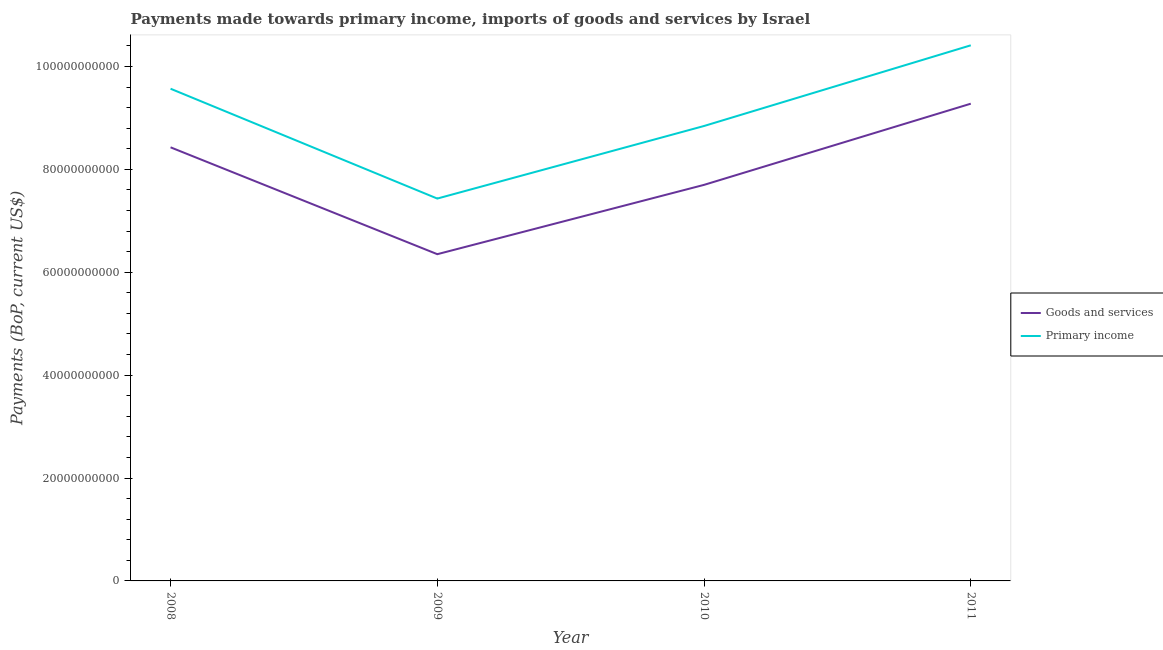What is the payments made towards goods and services in 2011?
Make the answer very short. 9.28e+1. Across all years, what is the maximum payments made towards goods and services?
Make the answer very short. 9.28e+1. Across all years, what is the minimum payments made towards primary income?
Keep it short and to the point. 7.43e+1. In which year was the payments made towards goods and services maximum?
Make the answer very short. 2011. What is the total payments made towards primary income in the graph?
Provide a succinct answer. 3.63e+11. What is the difference between the payments made towards goods and services in 2009 and that in 2011?
Keep it short and to the point. -2.93e+1. What is the difference between the payments made towards primary income in 2008 and the payments made towards goods and services in 2010?
Make the answer very short. 1.87e+1. What is the average payments made towards primary income per year?
Offer a terse response. 9.06e+1. In the year 2010, what is the difference between the payments made towards goods and services and payments made towards primary income?
Provide a succinct answer. -1.14e+1. What is the ratio of the payments made towards primary income in 2008 to that in 2010?
Keep it short and to the point. 1.08. Is the payments made towards goods and services in 2008 less than that in 2011?
Your answer should be compact. Yes. Is the difference between the payments made towards primary income in 2009 and 2011 greater than the difference between the payments made towards goods and services in 2009 and 2011?
Ensure brevity in your answer.  No. What is the difference between the highest and the second highest payments made towards primary income?
Offer a terse response. 8.44e+09. What is the difference between the highest and the lowest payments made towards goods and services?
Offer a very short reply. 2.93e+1. Does the payments made towards primary income monotonically increase over the years?
Ensure brevity in your answer.  No. How many lines are there?
Your answer should be compact. 2. How many years are there in the graph?
Make the answer very short. 4. What is the difference between two consecutive major ticks on the Y-axis?
Offer a very short reply. 2.00e+1. Are the values on the major ticks of Y-axis written in scientific E-notation?
Make the answer very short. No. How many legend labels are there?
Make the answer very short. 2. How are the legend labels stacked?
Provide a succinct answer. Vertical. What is the title of the graph?
Your answer should be compact. Payments made towards primary income, imports of goods and services by Israel. What is the label or title of the Y-axis?
Your response must be concise. Payments (BoP, current US$). What is the Payments (BoP, current US$) of Goods and services in 2008?
Give a very brief answer. 8.43e+1. What is the Payments (BoP, current US$) of Primary income in 2008?
Ensure brevity in your answer.  9.57e+1. What is the Payments (BoP, current US$) of Goods and services in 2009?
Your answer should be very brief. 6.35e+1. What is the Payments (BoP, current US$) in Primary income in 2009?
Give a very brief answer. 7.43e+1. What is the Payments (BoP, current US$) in Goods and services in 2010?
Your answer should be compact. 7.70e+1. What is the Payments (BoP, current US$) in Primary income in 2010?
Your answer should be compact. 8.84e+1. What is the Payments (BoP, current US$) of Goods and services in 2011?
Keep it short and to the point. 9.28e+1. What is the Payments (BoP, current US$) of Primary income in 2011?
Your response must be concise. 1.04e+11. Across all years, what is the maximum Payments (BoP, current US$) of Goods and services?
Provide a short and direct response. 9.28e+1. Across all years, what is the maximum Payments (BoP, current US$) in Primary income?
Your response must be concise. 1.04e+11. Across all years, what is the minimum Payments (BoP, current US$) of Goods and services?
Offer a terse response. 6.35e+1. Across all years, what is the minimum Payments (BoP, current US$) in Primary income?
Give a very brief answer. 7.43e+1. What is the total Payments (BoP, current US$) in Goods and services in the graph?
Provide a short and direct response. 3.18e+11. What is the total Payments (BoP, current US$) in Primary income in the graph?
Your response must be concise. 3.63e+11. What is the difference between the Payments (BoP, current US$) of Goods and services in 2008 and that in 2009?
Provide a short and direct response. 2.08e+1. What is the difference between the Payments (BoP, current US$) in Primary income in 2008 and that in 2009?
Give a very brief answer. 2.14e+1. What is the difference between the Payments (BoP, current US$) in Goods and services in 2008 and that in 2010?
Your answer should be compact. 7.30e+09. What is the difference between the Payments (BoP, current US$) in Primary income in 2008 and that in 2010?
Provide a short and direct response. 7.24e+09. What is the difference between the Payments (BoP, current US$) of Goods and services in 2008 and that in 2011?
Provide a succinct answer. -8.48e+09. What is the difference between the Payments (BoP, current US$) of Primary income in 2008 and that in 2011?
Provide a succinct answer. -8.44e+09. What is the difference between the Payments (BoP, current US$) in Goods and services in 2009 and that in 2010?
Ensure brevity in your answer.  -1.35e+1. What is the difference between the Payments (BoP, current US$) of Primary income in 2009 and that in 2010?
Give a very brief answer. -1.41e+1. What is the difference between the Payments (BoP, current US$) of Goods and services in 2009 and that in 2011?
Your answer should be very brief. -2.93e+1. What is the difference between the Payments (BoP, current US$) of Primary income in 2009 and that in 2011?
Your answer should be compact. -2.98e+1. What is the difference between the Payments (BoP, current US$) of Goods and services in 2010 and that in 2011?
Your response must be concise. -1.58e+1. What is the difference between the Payments (BoP, current US$) in Primary income in 2010 and that in 2011?
Your answer should be compact. -1.57e+1. What is the difference between the Payments (BoP, current US$) in Goods and services in 2008 and the Payments (BoP, current US$) in Primary income in 2009?
Your answer should be very brief. 9.96e+09. What is the difference between the Payments (BoP, current US$) of Goods and services in 2008 and the Payments (BoP, current US$) of Primary income in 2010?
Provide a succinct answer. -4.15e+09. What is the difference between the Payments (BoP, current US$) in Goods and services in 2008 and the Payments (BoP, current US$) in Primary income in 2011?
Provide a succinct answer. -1.98e+1. What is the difference between the Payments (BoP, current US$) of Goods and services in 2009 and the Payments (BoP, current US$) of Primary income in 2010?
Your answer should be very brief. -2.49e+1. What is the difference between the Payments (BoP, current US$) of Goods and services in 2009 and the Payments (BoP, current US$) of Primary income in 2011?
Your response must be concise. -4.06e+1. What is the difference between the Payments (BoP, current US$) of Goods and services in 2010 and the Payments (BoP, current US$) of Primary income in 2011?
Your answer should be very brief. -2.71e+1. What is the average Payments (BoP, current US$) in Goods and services per year?
Your response must be concise. 7.94e+1. What is the average Payments (BoP, current US$) in Primary income per year?
Provide a short and direct response. 9.06e+1. In the year 2008, what is the difference between the Payments (BoP, current US$) of Goods and services and Payments (BoP, current US$) of Primary income?
Provide a succinct answer. -1.14e+1. In the year 2009, what is the difference between the Payments (BoP, current US$) in Goods and services and Payments (BoP, current US$) in Primary income?
Provide a succinct answer. -1.08e+1. In the year 2010, what is the difference between the Payments (BoP, current US$) of Goods and services and Payments (BoP, current US$) of Primary income?
Your answer should be compact. -1.14e+1. In the year 2011, what is the difference between the Payments (BoP, current US$) in Goods and services and Payments (BoP, current US$) in Primary income?
Keep it short and to the point. -1.13e+1. What is the ratio of the Payments (BoP, current US$) in Goods and services in 2008 to that in 2009?
Offer a very short reply. 1.33. What is the ratio of the Payments (BoP, current US$) in Primary income in 2008 to that in 2009?
Give a very brief answer. 1.29. What is the ratio of the Payments (BoP, current US$) in Goods and services in 2008 to that in 2010?
Your answer should be compact. 1.09. What is the ratio of the Payments (BoP, current US$) of Primary income in 2008 to that in 2010?
Your answer should be very brief. 1.08. What is the ratio of the Payments (BoP, current US$) in Goods and services in 2008 to that in 2011?
Make the answer very short. 0.91. What is the ratio of the Payments (BoP, current US$) in Primary income in 2008 to that in 2011?
Offer a terse response. 0.92. What is the ratio of the Payments (BoP, current US$) of Goods and services in 2009 to that in 2010?
Keep it short and to the point. 0.82. What is the ratio of the Payments (BoP, current US$) of Primary income in 2009 to that in 2010?
Your response must be concise. 0.84. What is the ratio of the Payments (BoP, current US$) in Goods and services in 2009 to that in 2011?
Your answer should be very brief. 0.68. What is the ratio of the Payments (BoP, current US$) in Primary income in 2009 to that in 2011?
Keep it short and to the point. 0.71. What is the ratio of the Payments (BoP, current US$) in Goods and services in 2010 to that in 2011?
Ensure brevity in your answer.  0.83. What is the ratio of the Payments (BoP, current US$) of Primary income in 2010 to that in 2011?
Keep it short and to the point. 0.85. What is the difference between the highest and the second highest Payments (BoP, current US$) in Goods and services?
Make the answer very short. 8.48e+09. What is the difference between the highest and the second highest Payments (BoP, current US$) in Primary income?
Your answer should be very brief. 8.44e+09. What is the difference between the highest and the lowest Payments (BoP, current US$) of Goods and services?
Your response must be concise. 2.93e+1. What is the difference between the highest and the lowest Payments (BoP, current US$) of Primary income?
Your answer should be very brief. 2.98e+1. 